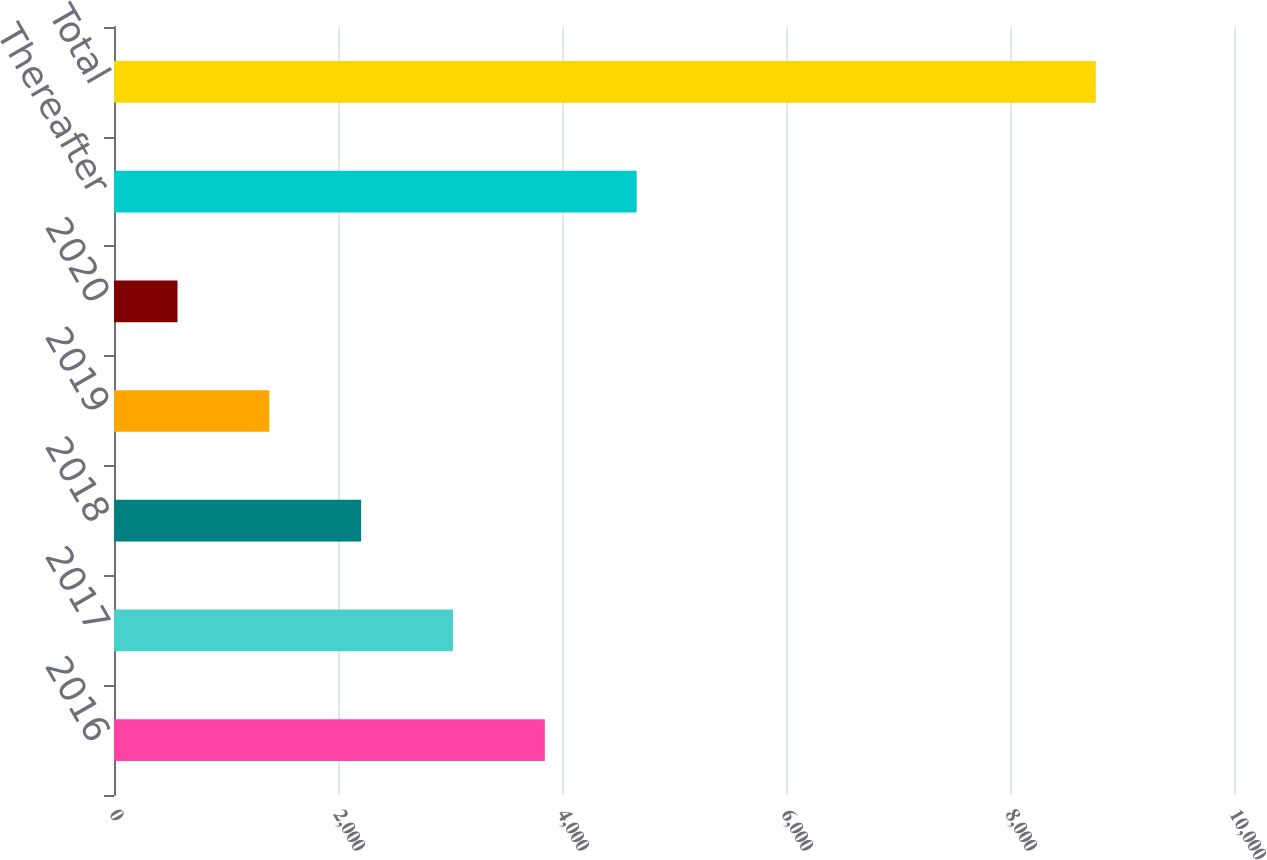Convert chart to OTSL. <chart><loc_0><loc_0><loc_500><loc_500><bar_chart><fcel>2016<fcel>2017<fcel>2018<fcel>2019<fcel>2020<fcel>Thereafter<fcel>Total<nl><fcel>3846.6<fcel>3026.7<fcel>2206.8<fcel>1386.9<fcel>567<fcel>4666.5<fcel>8766<nl></chart> 